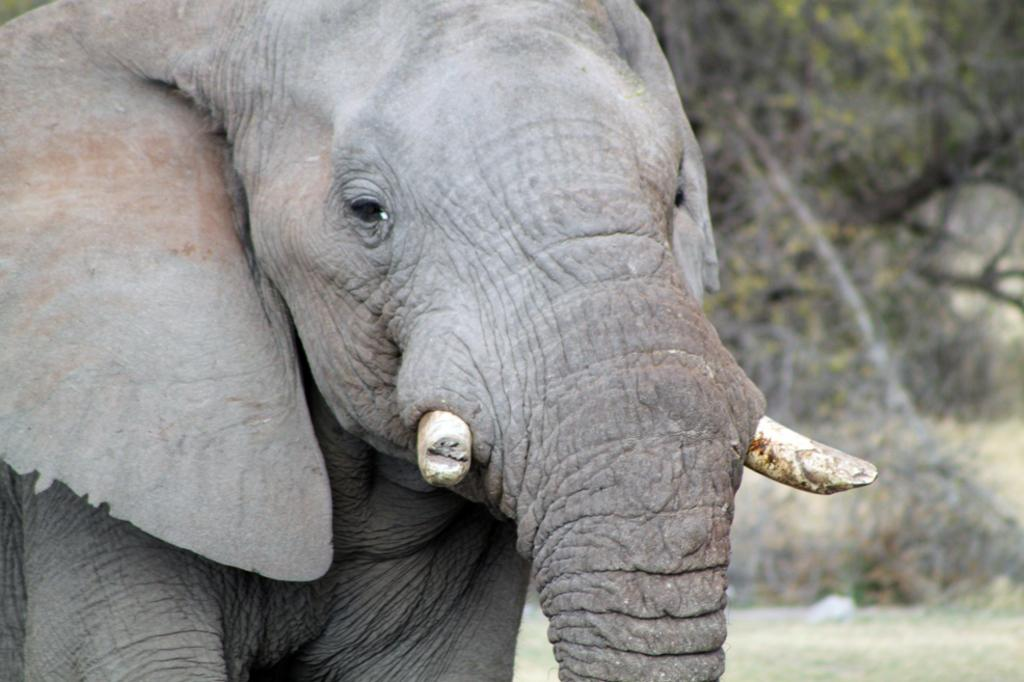What animal is the main subject of the picture? There is an elephant in the picture. How would you describe the background of the image? The background of the image is blurred. What type of vegetation can be seen in the background? There are trees, plants, and grass in the background of the image. How many tickets are required for the coach to travel in the image? There is no coach or tickets present in the image; it features an elephant and a blurred background with vegetation. 